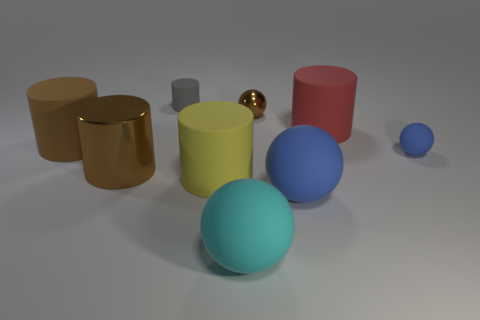Does the cylinder to the right of the cyan ball have the same size as the brown shiny ball?
Make the answer very short. No. There is another brown object that is the same size as the brown matte object; what is its material?
Keep it short and to the point. Metal. Is the big yellow object made of the same material as the brown object that is to the right of the small gray matte cylinder?
Keep it short and to the point. No. What number of other brown objects have the same shape as the large brown metallic object?
Your answer should be compact. 1. What is the material of the ball that is the same color as the metallic cylinder?
Offer a very short reply. Metal. What number of small blue shiny cylinders are there?
Keep it short and to the point. 0. There is a large cyan object; is its shape the same as the shiny thing in front of the small blue object?
Your answer should be compact. No. What number of objects are either small rubber objects or big balls that are on the right side of the cyan rubber object?
Provide a succinct answer. 3. There is a cyan object that is the same shape as the tiny brown shiny object; what is it made of?
Your response must be concise. Rubber. There is a cyan thing on the left side of the small brown thing; is it the same shape as the brown matte thing?
Your answer should be very brief. No. 